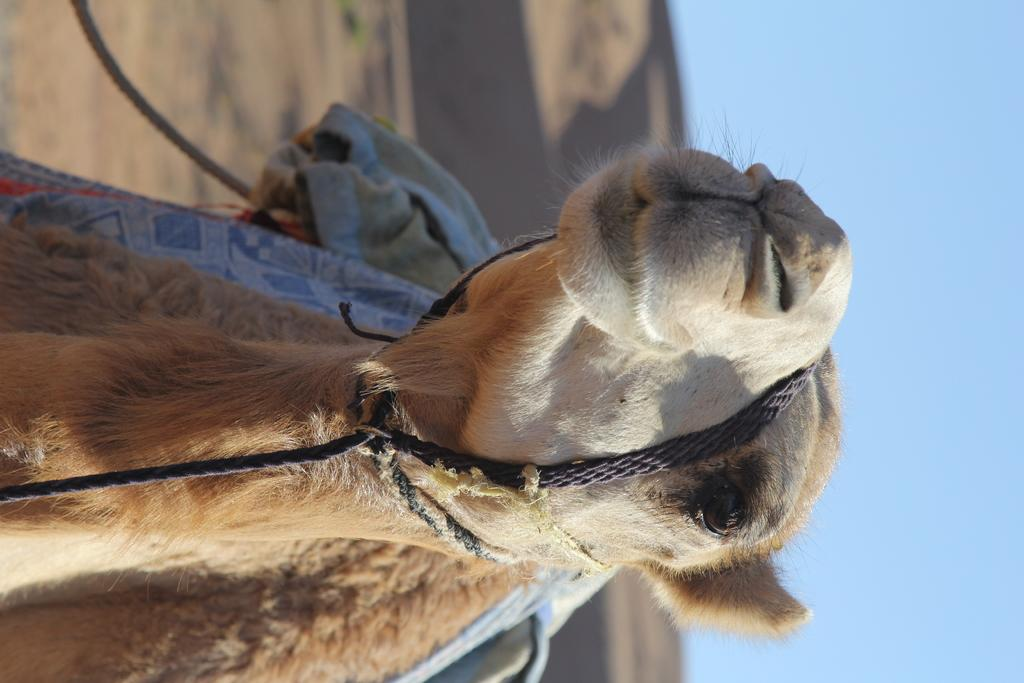What animal is the main subject of the image? There is a camel in the image. Are there any objects attached to the camel? Yes, the camel has ropes and other objects on it. What can be seen in the background of the image? The sky is visible in the background of the image. How would you describe the background's appearance? The background of the image is blurred. What type of paper is being used as a veil on the camel in the image? There is no paper or veil present on the camel in the image. What song is being played in the background of the image? There is no song or audio present in the image; it is a still photograph. 